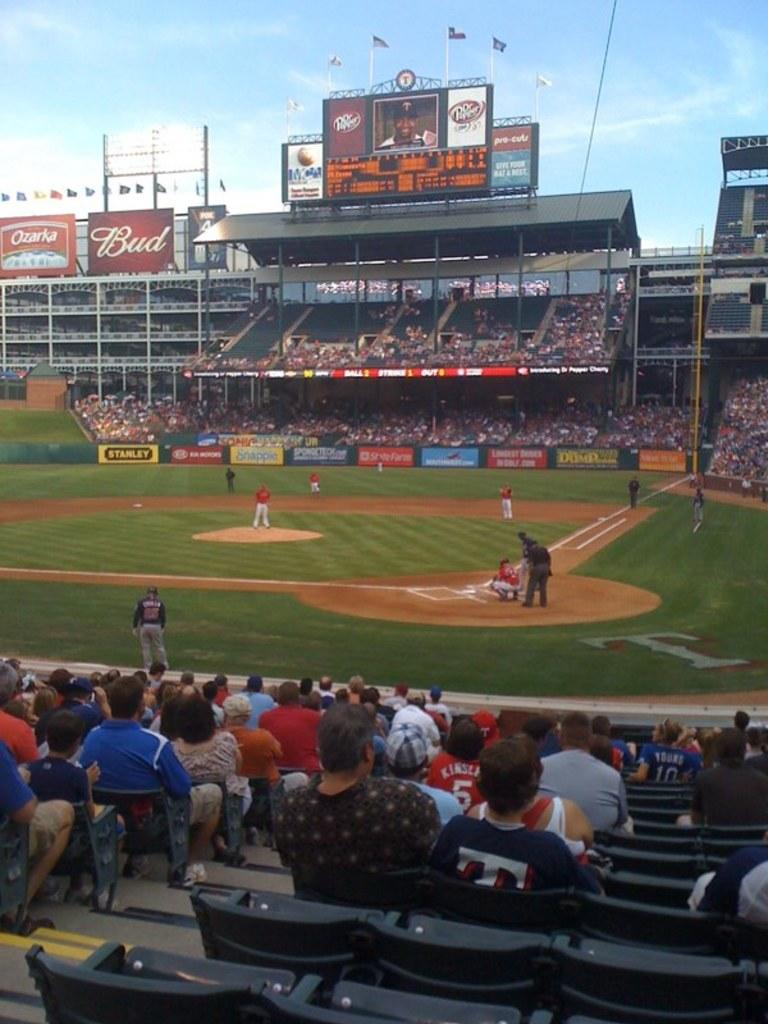<image>
Summarize the visual content of the image. A baseball field with Budweiser ads in the background 